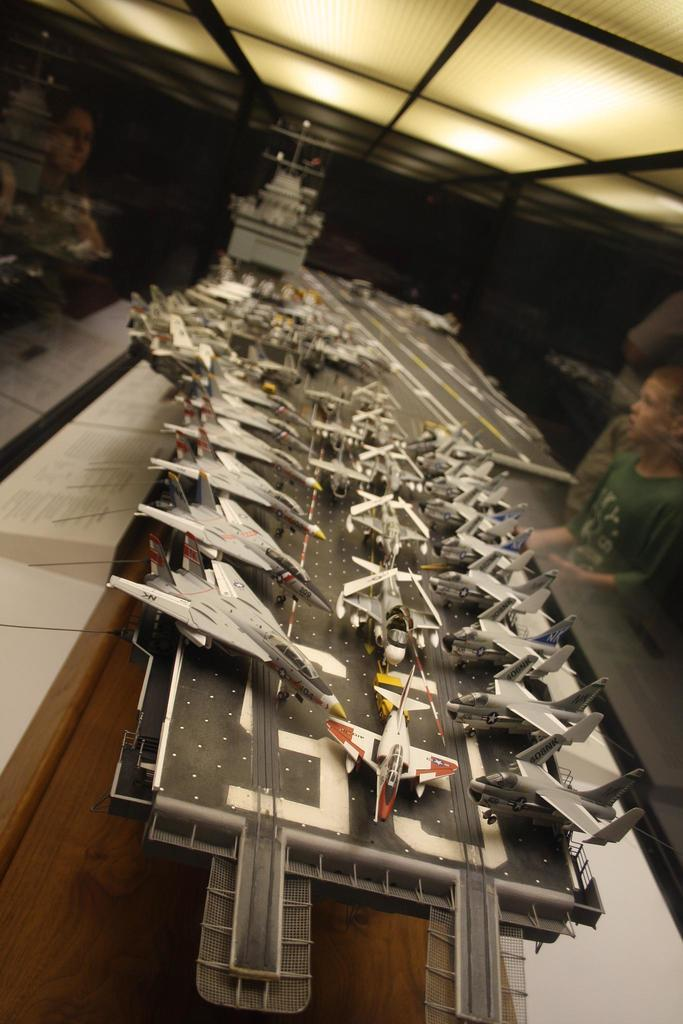What type of miniature vehicles are present in the image? There is a miniature of a warship and a miniature of an aircraft in the image. What else can be seen near the miniatures? There are people near the miniatures. What can be observed in the background of the image? There are lights visible in the background of the image. How many pizzas are being served to the frogs in the image? There are no frogs or pizzas present in the image. 